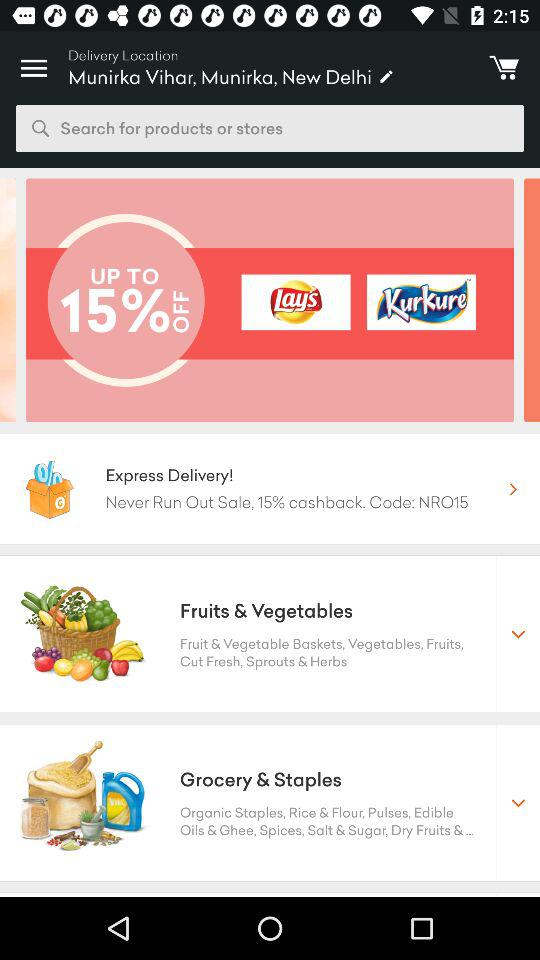What is the 15% cashback code? The code is "NRO15". 